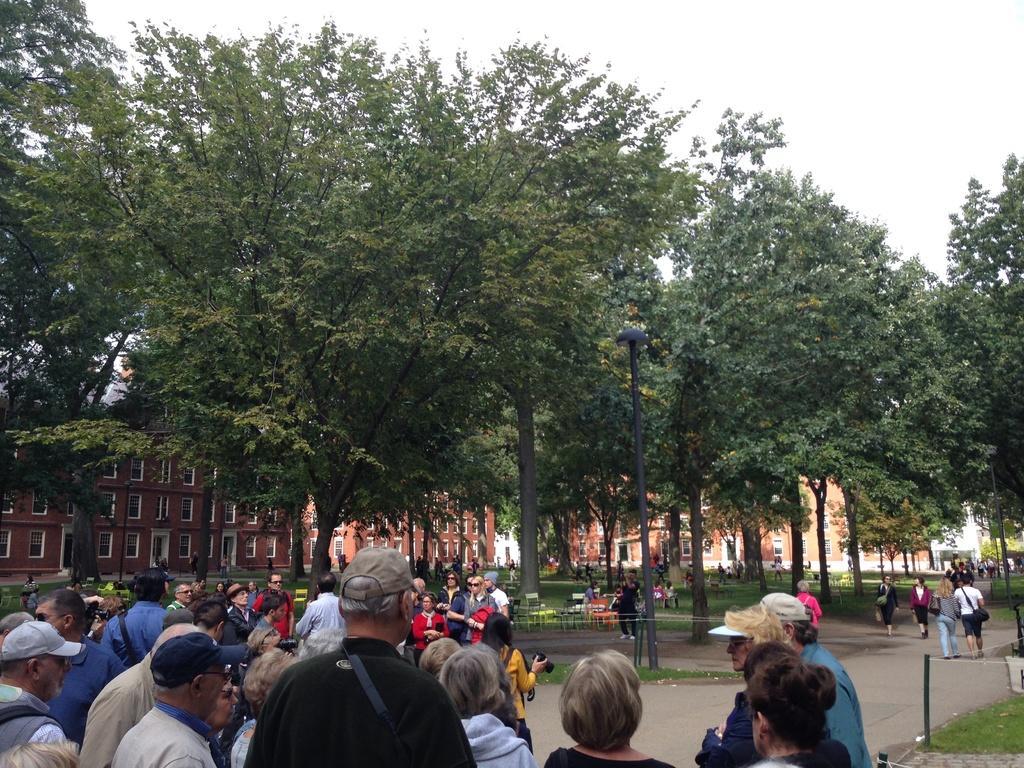Can you describe this image briefly? In this image, we can see some trees and buildings. There is a crowd at the bottom of the image wearing clothes. There are poles in the middle of the image. There is a sky at the top of the image. 